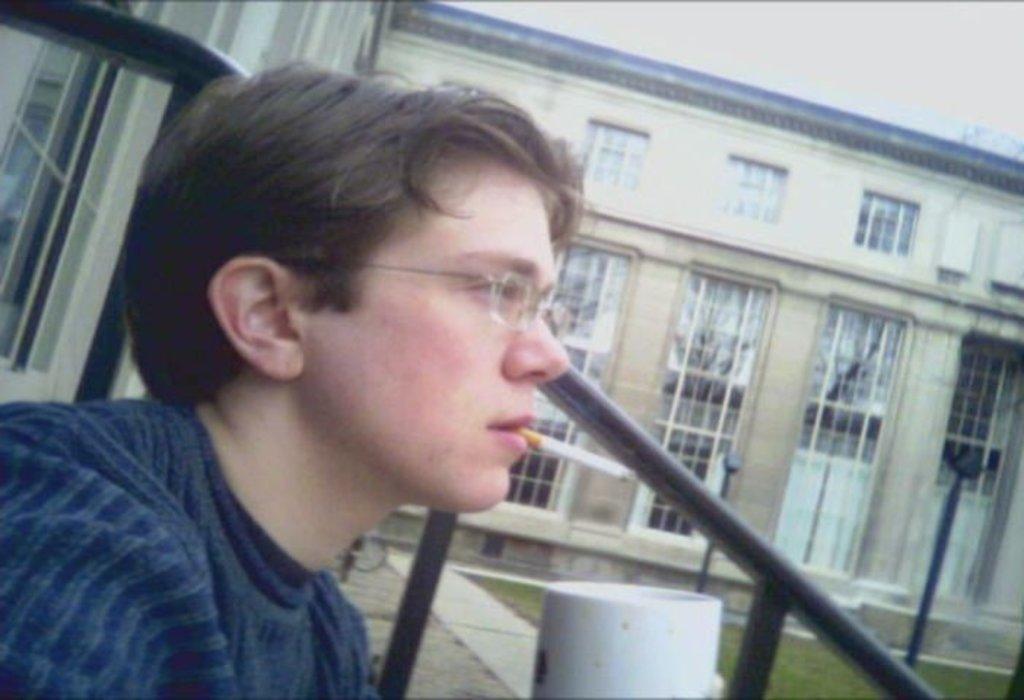Can you describe this image briefly? In this image we can see a person wearing spectacles is holding a cigarette in his mouth. In the background, we can see metal rods, group of poles, building with windows and the sky. 